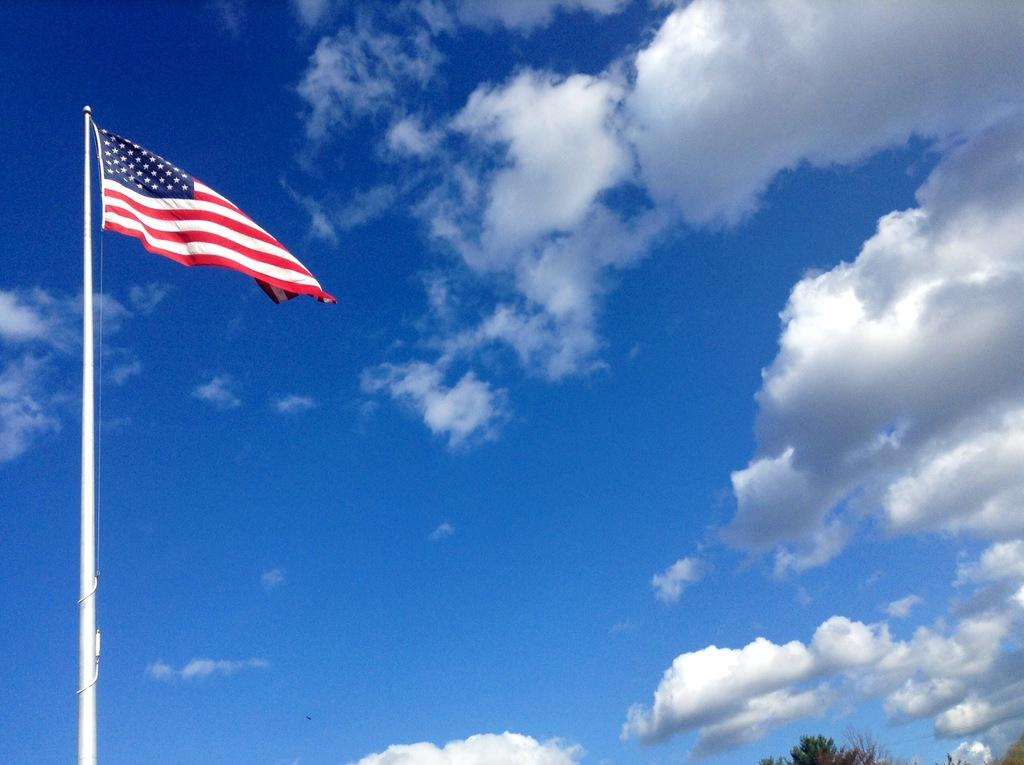What is on the pole in the image? There is a flag on a pole in the image. What is located at the bottom of the image? There is a tree at the bottom of the image. What can be seen in the background of the image? The sky is visible in the background of the image. What is present in the sky? Clouds are present in the sky. How many frogs are sitting on the pen in the image? There is no pen or frogs present in the image. What type of turkey can be seen flying in the sky? There is no turkey present in the image; only a flag, a tree, and clouds are visible in the sky. 